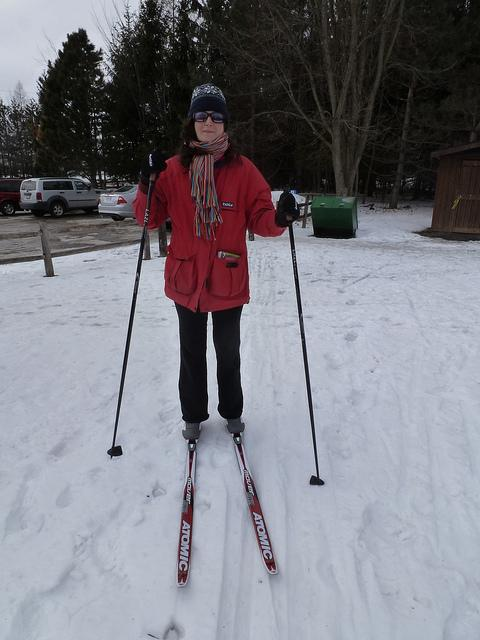Why is the woman wearing the covering around her neck? Please explain your reasoning. keeping warm. The woman is covering her neck with a scarf to keep warm during winter. 